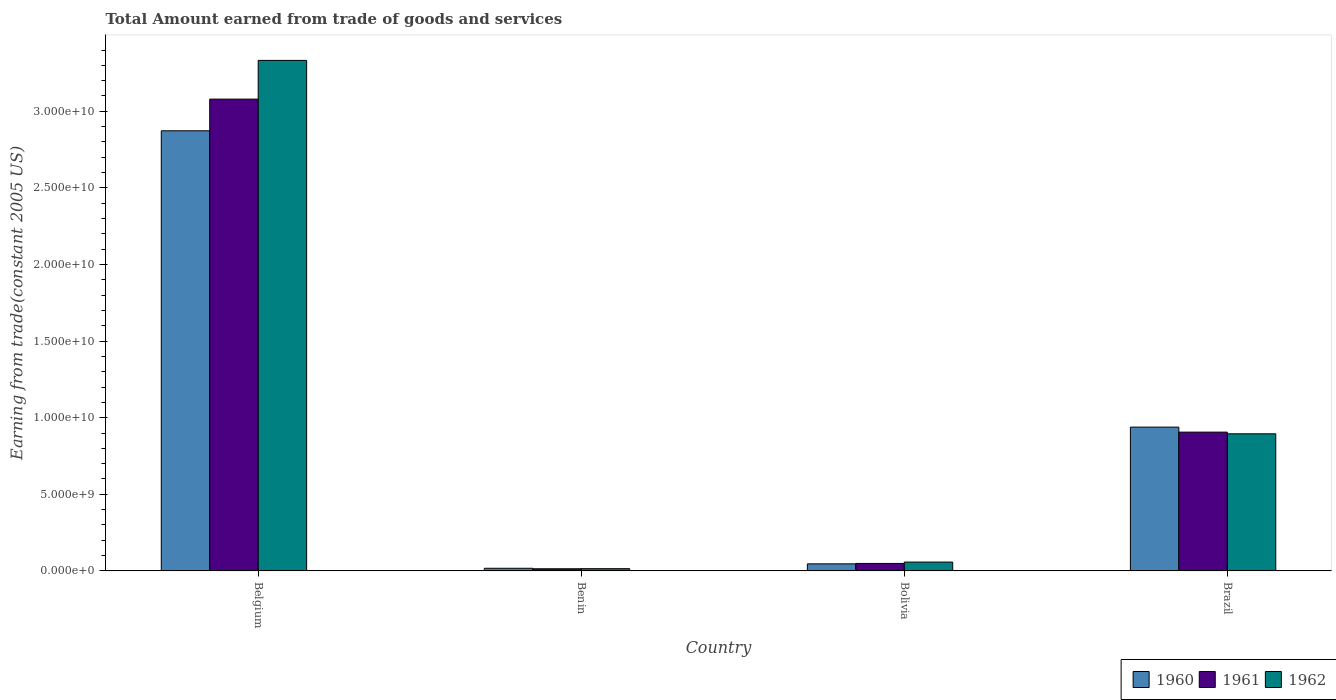How many different coloured bars are there?
Your answer should be compact. 3. How many groups of bars are there?
Give a very brief answer. 4. How many bars are there on the 2nd tick from the right?
Your answer should be very brief. 3. In how many cases, is the number of bars for a given country not equal to the number of legend labels?
Make the answer very short. 0. What is the total amount earned by trading goods and services in 1962 in Belgium?
Provide a short and direct response. 3.33e+1. Across all countries, what is the maximum total amount earned by trading goods and services in 1960?
Give a very brief answer. 2.87e+1. Across all countries, what is the minimum total amount earned by trading goods and services in 1961?
Provide a short and direct response. 1.39e+08. In which country was the total amount earned by trading goods and services in 1960 minimum?
Give a very brief answer. Benin. What is the total total amount earned by trading goods and services in 1961 in the graph?
Offer a terse response. 4.05e+1. What is the difference between the total amount earned by trading goods and services in 1961 in Belgium and that in Brazil?
Your response must be concise. 2.17e+1. What is the difference between the total amount earned by trading goods and services in 1960 in Benin and the total amount earned by trading goods and services in 1962 in Bolivia?
Make the answer very short. -4.05e+08. What is the average total amount earned by trading goods and services in 1962 per country?
Make the answer very short. 1.07e+1. What is the difference between the total amount earned by trading goods and services of/in 1962 and total amount earned by trading goods and services of/in 1960 in Benin?
Ensure brevity in your answer.  -2.63e+07. In how many countries, is the total amount earned by trading goods and services in 1962 greater than 22000000000 US$?
Keep it short and to the point. 1. What is the ratio of the total amount earned by trading goods and services in 1961 in Belgium to that in Benin?
Offer a terse response. 221.9. Is the total amount earned by trading goods and services in 1961 in Benin less than that in Bolivia?
Keep it short and to the point. Yes. What is the difference between the highest and the second highest total amount earned by trading goods and services in 1961?
Make the answer very short. 3.03e+1. What is the difference between the highest and the lowest total amount earned by trading goods and services in 1960?
Your answer should be compact. 2.86e+1. What does the 1st bar from the left in Belgium represents?
Your answer should be very brief. 1960. What does the 1st bar from the right in Bolivia represents?
Your answer should be very brief. 1962. How many bars are there?
Your response must be concise. 12. Are all the bars in the graph horizontal?
Your answer should be very brief. No. How many countries are there in the graph?
Offer a very short reply. 4. What is the difference between two consecutive major ticks on the Y-axis?
Keep it short and to the point. 5.00e+09. Are the values on the major ticks of Y-axis written in scientific E-notation?
Give a very brief answer. Yes. How many legend labels are there?
Ensure brevity in your answer.  3. How are the legend labels stacked?
Provide a succinct answer. Horizontal. What is the title of the graph?
Make the answer very short. Total Amount earned from trade of goods and services. What is the label or title of the Y-axis?
Provide a short and direct response. Earning from trade(constant 2005 US). What is the Earning from trade(constant 2005 US) of 1960 in Belgium?
Your answer should be compact. 2.87e+1. What is the Earning from trade(constant 2005 US) of 1961 in Belgium?
Ensure brevity in your answer.  3.08e+1. What is the Earning from trade(constant 2005 US) in 1962 in Belgium?
Make the answer very short. 3.33e+1. What is the Earning from trade(constant 2005 US) in 1960 in Benin?
Your response must be concise. 1.71e+08. What is the Earning from trade(constant 2005 US) in 1961 in Benin?
Your answer should be very brief. 1.39e+08. What is the Earning from trade(constant 2005 US) of 1962 in Benin?
Your response must be concise. 1.45e+08. What is the Earning from trade(constant 2005 US) of 1960 in Bolivia?
Ensure brevity in your answer.  4.60e+08. What is the Earning from trade(constant 2005 US) of 1961 in Bolivia?
Provide a succinct answer. 4.87e+08. What is the Earning from trade(constant 2005 US) in 1962 in Bolivia?
Keep it short and to the point. 5.76e+08. What is the Earning from trade(constant 2005 US) of 1960 in Brazil?
Provide a succinct answer. 9.39e+09. What is the Earning from trade(constant 2005 US) of 1961 in Brazil?
Give a very brief answer. 9.06e+09. What is the Earning from trade(constant 2005 US) of 1962 in Brazil?
Provide a succinct answer. 8.95e+09. Across all countries, what is the maximum Earning from trade(constant 2005 US) of 1960?
Make the answer very short. 2.87e+1. Across all countries, what is the maximum Earning from trade(constant 2005 US) in 1961?
Offer a terse response. 3.08e+1. Across all countries, what is the maximum Earning from trade(constant 2005 US) in 1962?
Provide a short and direct response. 3.33e+1. Across all countries, what is the minimum Earning from trade(constant 2005 US) of 1960?
Your answer should be very brief. 1.71e+08. Across all countries, what is the minimum Earning from trade(constant 2005 US) of 1961?
Give a very brief answer. 1.39e+08. Across all countries, what is the minimum Earning from trade(constant 2005 US) of 1962?
Your answer should be compact. 1.45e+08. What is the total Earning from trade(constant 2005 US) of 1960 in the graph?
Ensure brevity in your answer.  3.87e+1. What is the total Earning from trade(constant 2005 US) in 1961 in the graph?
Your response must be concise. 4.05e+1. What is the total Earning from trade(constant 2005 US) in 1962 in the graph?
Keep it short and to the point. 4.30e+1. What is the difference between the Earning from trade(constant 2005 US) in 1960 in Belgium and that in Benin?
Your response must be concise. 2.86e+1. What is the difference between the Earning from trade(constant 2005 US) of 1961 in Belgium and that in Benin?
Provide a short and direct response. 3.07e+1. What is the difference between the Earning from trade(constant 2005 US) of 1962 in Belgium and that in Benin?
Provide a short and direct response. 3.32e+1. What is the difference between the Earning from trade(constant 2005 US) of 1960 in Belgium and that in Bolivia?
Your answer should be compact. 2.83e+1. What is the difference between the Earning from trade(constant 2005 US) in 1961 in Belgium and that in Bolivia?
Your answer should be compact. 3.03e+1. What is the difference between the Earning from trade(constant 2005 US) in 1962 in Belgium and that in Bolivia?
Your response must be concise. 3.27e+1. What is the difference between the Earning from trade(constant 2005 US) in 1960 in Belgium and that in Brazil?
Make the answer very short. 1.93e+1. What is the difference between the Earning from trade(constant 2005 US) of 1961 in Belgium and that in Brazil?
Offer a very short reply. 2.17e+1. What is the difference between the Earning from trade(constant 2005 US) of 1962 in Belgium and that in Brazil?
Provide a short and direct response. 2.44e+1. What is the difference between the Earning from trade(constant 2005 US) in 1960 in Benin and that in Bolivia?
Offer a terse response. -2.88e+08. What is the difference between the Earning from trade(constant 2005 US) of 1961 in Benin and that in Bolivia?
Keep it short and to the point. -3.48e+08. What is the difference between the Earning from trade(constant 2005 US) in 1962 in Benin and that in Bolivia?
Make the answer very short. -4.31e+08. What is the difference between the Earning from trade(constant 2005 US) of 1960 in Benin and that in Brazil?
Provide a succinct answer. -9.21e+09. What is the difference between the Earning from trade(constant 2005 US) of 1961 in Benin and that in Brazil?
Provide a short and direct response. -8.92e+09. What is the difference between the Earning from trade(constant 2005 US) of 1962 in Benin and that in Brazil?
Provide a short and direct response. -8.80e+09. What is the difference between the Earning from trade(constant 2005 US) of 1960 in Bolivia and that in Brazil?
Your response must be concise. -8.93e+09. What is the difference between the Earning from trade(constant 2005 US) in 1961 in Bolivia and that in Brazil?
Your answer should be compact. -8.57e+09. What is the difference between the Earning from trade(constant 2005 US) of 1962 in Bolivia and that in Brazil?
Make the answer very short. -8.37e+09. What is the difference between the Earning from trade(constant 2005 US) of 1960 in Belgium and the Earning from trade(constant 2005 US) of 1961 in Benin?
Keep it short and to the point. 2.86e+1. What is the difference between the Earning from trade(constant 2005 US) in 1960 in Belgium and the Earning from trade(constant 2005 US) in 1962 in Benin?
Your response must be concise. 2.86e+1. What is the difference between the Earning from trade(constant 2005 US) of 1961 in Belgium and the Earning from trade(constant 2005 US) of 1962 in Benin?
Offer a very short reply. 3.07e+1. What is the difference between the Earning from trade(constant 2005 US) in 1960 in Belgium and the Earning from trade(constant 2005 US) in 1961 in Bolivia?
Provide a succinct answer. 2.82e+1. What is the difference between the Earning from trade(constant 2005 US) in 1960 in Belgium and the Earning from trade(constant 2005 US) in 1962 in Bolivia?
Offer a very short reply. 2.82e+1. What is the difference between the Earning from trade(constant 2005 US) of 1961 in Belgium and the Earning from trade(constant 2005 US) of 1962 in Bolivia?
Keep it short and to the point. 3.02e+1. What is the difference between the Earning from trade(constant 2005 US) in 1960 in Belgium and the Earning from trade(constant 2005 US) in 1961 in Brazil?
Ensure brevity in your answer.  1.97e+1. What is the difference between the Earning from trade(constant 2005 US) of 1960 in Belgium and the Earning from trade(constant 2005 US) of 1962 in Brazil?
Make the answer very short. 1.98e+1. What is the difference between the Earning from trade(constant 2005 US) of 1961 in Belgium and the Earning from trade(constant 2005 US) of 1962 in Brazil?
Your answer should be compact. 2.18e+1. What is the difference between the Earning from trade(constant 2005 US) in 1960 in Benin and the Earning from trade(constant 2005 US) in 1961 in Bolivia?
Keep it short and to the point. -3.15e+08. What is the difference between the Earning from trade(constant 2005 US) in 1960 in Benin and the Earning from trade(constant 2005 US) in 1962 in Bolivia?
Offer a terse response. -4.05e+08. What is the difference between the Earning from trade(constant 2005 US) in 1961 in Benin and the Earning from trade(constant 2005 US) in 1962 in Bolivia?
Your answer should be very brief. -4.38e+08. What is the difference between the Earning from trade(constant 2005 US) in 1960 in Benin and the Earning from trade(constant 2005 US) in 1961 in Brazil?
Offer a very short reply. -8.89e+09. What is the difference between the Earning from trade(constant 2005 US) in 1960 in Benin and the Earning from trade(constant 2005 US) in 1962 in Brazil?
Make the answer very short. -8.78e+09. What is the difference between the Earning from trade(constant 2005 US) of 1961 in Benin and the Earning from trade(constant 2005 US) of 1962 in Brazil?
Make the answer very short. -8.81e+09. What is the difference between the Earning from trade(constant 2005 US) in 1960 in Bolivia and the Earning from trade(constant 2005 US) in 1961 in Brazil?
Give a very brief answer. -8.60e+09. What is the difference between the Earning from trade(constant 2005 US) in 1960 in Bolivia and the Earning from trade(constant 2005 US) in 1962 in Brazil?
Ensure brevity in your answer.  -8.49e+09. What is the difference between the Earning from trade(constant 2005 US) of 1961 in Bolivia and the Earning from trade(constant 2005 US) of 1962 in Brazil?
Provide a succinct answer. -8.46e+09. What is the average Earning from trade(constant 2005 US) of 1960 per country?
Keep it short and to the point. 9.69e+09. What is the average Earning from trade(constant 2005 US) in 1961 per country?
Offer a terse response. 1.01e+1. What is the average Earning from trade(constant 2005 US) in 1962 per country?
Offer a very short reply. 1.07e+1. What is the difference between the Earning from trade(constant 2005 US) in 1960 and Earning from trade(constant 2005 US) in 1961 in Belgium?
Make the answer very short. -2.07e+09. What is the difference between the Earning from trade(constant 2005 US) in 1960 and Earning from trade(constant 2005 US) in 1962 in Belgium?
Provide a succinct answer. -4.59e+09. What is the difference between the Earning from trade(constant 2005 US) of 1961 and Earning from trade(constant 2005 US) of 1962 in Belgium?
Your response must be concise. -2.53e+09. What is the difference between the Earning from trade(constant 2005 US) of 1960 and Earning from trade(constant 2005 US) of 1961 in Benin?
Offer a very short reply. 3.26e+07. What is the difference between the Earning from trade(constant 2005 US) of 1960 and Earning from trade(constant 2005 US) of 1962 in Benin?
Keep it short and to the point. 2.63e+07. What is the difference between the Earning from trade(constant 2005 US) of 1961 and Earning from trade(constant 2005 US) of 1962 in Benin?
Give a very brief answer. -6.31e+06. What is the difference between the Earning from trade(constant 2005 US) of 1960 and Earning from trade(constant 2005 US) of 1961 in Bolivia?
Ensure brevity in your answer.  -2.69e+07. What is the difference between the Earning from trade(constant 2005 US) of 1960 and Earning from trade(constant 2005 US) of 1962 in Bolivia?
Offer a terse response. -1.17e+08. What is the difference between the Earning from trade(constant 2005 US) of 1961 and Earning from trade(constant 2005 US) of 1962 in Bolivia?
Your answer should be very brief. -8.97e+07. What is the difference between the Earning from trade(constant 2005 US) of 1960 and Earning from trade(constant 2005 US) of 1961 in Brazil?
Make the answer very short. 3.27e+08. What is the difference between the Earning from trade(constant 2005 US) of 1960 and Earning from trade(constant 2005 US) of 1962 in Brazil?
Provide a short and direct response. 4.36e+08. What is the difference between the Earning from trade(constant 2005 US) in 1961 and Earning from trade(constant 2005 US) in 1962 in Brazil?
Offer a terse response. 1.09e+08. What is the ratio of the Earning from trade(constant 2005 US) of 1960 in Belgium to that in Benin?
Your response must be concise. 167.64. What is the ratio of the Earning from trade(constant 2005 US) of 1961 in Belgium to that in Benin?
Ensure brevity in your answer.  221.9. What is the ratio of the Earning from trade(constant 2005 US) in 1962 in Belgium to that in Benin?
Offer a terse response. 229.68. What is the ratio of the Earning from trade(constant 2005 US) in 1960 in Belgium to that in Bolivia?
Provide a short and direct response. 62.48. What is the ratio of the Earning from trade(constant 2005 US) in 1961 in Belgium to that in Bolivia?
Your response must be concise. 63.27. What is the ratio of the Earning from trade(constant 2005 US) of 1962 in Belgium to that in Bolivia?
Your answer should be compact. 57.81. What is the ratio of the Earning from trade(constant 2005 US) of 1960 in Belgium to that in Brazil?
Give a very brief answer. 3.06. What is the ratio of the Earning from trade(constant 2005 US) in 1961 in Belgium to that in Brazil?
Provide a succinct answer. 3.4. What is the ratio of the Earning from trade(constant 2005 US) in 1962 in Belgium to that in Brazil?
Offer a very short reply. 3.72. What is the ratio of the Earning from trade(constant 2005 US) of 1960 in Benin to that in Bolivia?
Keep it short and to the point. 0.37. What is the ratio of the Earning from trade(constant 2005 US) of 1961 in Benin to that in Bolivia?
Provide a short and direct response. 0.29. What is the ratio of the Earning from trade(constant 2005 US) of 1962 in Benin to that in Bolivia?
Offer a terse response. 0.25. What is the ratio of the Earning from trade(constant 2005 US) in 1960 in Benin to that in Brazil?
Give a very brief answer. 0.02. What is the ratio of the Earning from trade(constant 2005 US) of 1961 in Benin to that in Brazil?
Keep it short and to the point. 0.02. What is the ratio of the Earning from trade(constant 2005 US) in 1962 in Benin to that in Brazil?
Keep it short and to the point. 0.02. What is the ratio of the Earning from trade(constant 2005 US) of 1960 in Bolivia to that in Brazil?
Offer a very short reply. 0.05. What is the ratio of the Earning from trade(constant 2005 US) in 1961 in Bolivia to that in Brazil?
Provide a short and direct response. 0.05. What is the ratio of the Earning from trade(constant 2005 US) in 1962 in Bolivia to that in Brazil?
Provide a succinct answer. 0.06. What is the difference between the highest and the second highest Earning from trade(constant 2005 US) of 1960?
Provide a succinct answer. 1.93e+1. What is the difference between the highest and the second highest Earning from trade(constant 2005 US) of 1961?
Your answer should be compact. 2.17e+1. What is the difference between the highest and the second highest Earning from trade(constant 2005 US) of 1962?
Offer a very short reply. 2.44e+1. What is the difference between the highest and the lowest Earning from trade(constant 2005 US) in 1960?
Provide a succinct answer. 2.86e+1. What is the difference between the highest and the lowest Earning from trade(constant 2005 US) in 1961?
Provide a succinct answer. 3.07e+1. What is the difference between the highest and the lowest Earning from trade(constant 2005 US) in 1962?
Offer a terse response. 3.32e+1. 